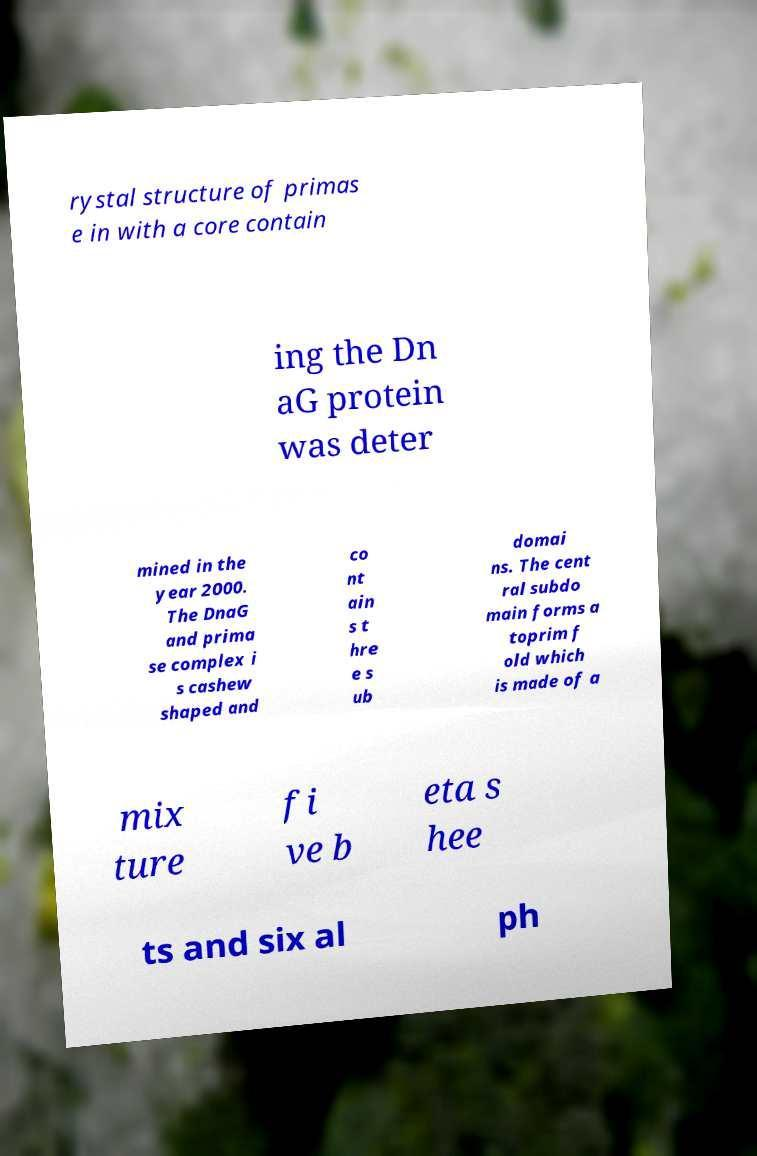Please read and relay the text visible in this image. What does it say? rystal structure of primas e in with a core contain ing the Dn aG protein was deter mined in the year 2000. The DnaG and prima se complex i s cashew shaped and co nt ain s t hre e s ub domai ns. The cent ral subdo main forms a toprim f old which is made of a mix ture fi ve b eta s hee ts and six al ph 